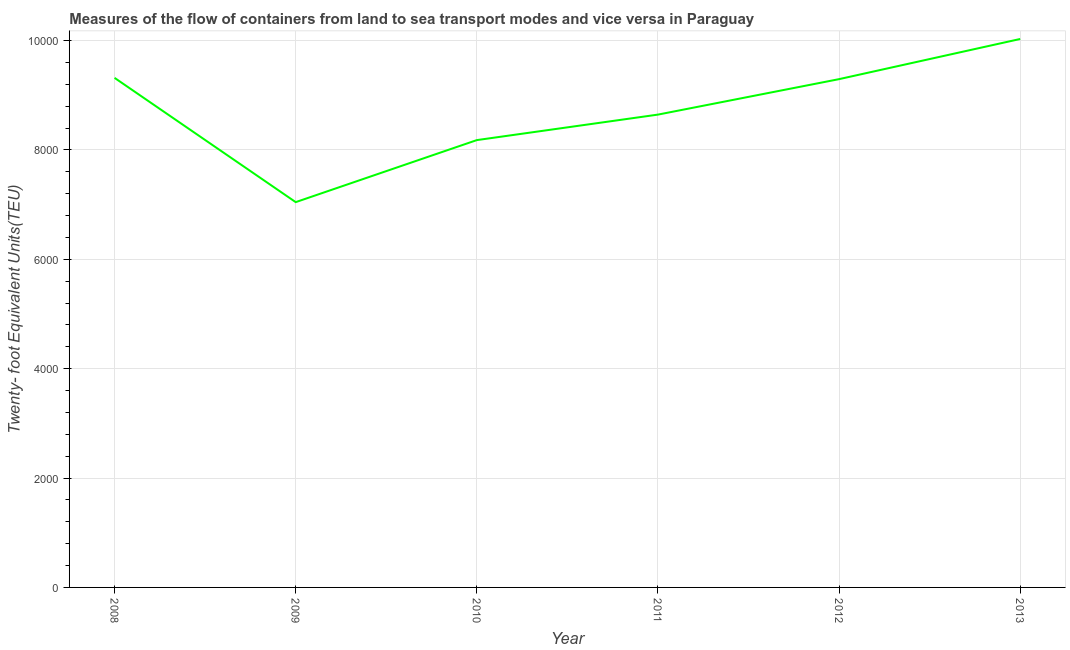What is the container port traffic in 2008?
Make the answer very short. 9317. Across all years, what is the maximum container port traffic?
Your response must be concise. 1.00e+04. Across all years, what is the minimum container port traffic?
Your answer should be very brief. 7045. In which year was the container port traffic maximum?
Your response must be concise. 2013. In which year was the container port traffic minimum?
Your answer should be very brief. 2009. What is the sum of the container port traffic?
Your response must be concise. 5.25e+04. What is the difference between the container port traffic in 2009 and 2013?
Provide a succinct answer. -2983.09. What is the average container port traffic per year?
Provide a short and direct response. 8751.44. What is the median container port traffic?
Make the answer very short. 8969.67. In how many years, is the container port traffic greater than 8400 TEU?
Offer a terse response. 4. What is the ratio of the container port traffic in 2010 to that in 2012?
Your answer should be very brief. 0.88. Is the container port traffic in 2008 less than that in 2009?
Your response must be concise. No. Is the difference between the container port traffic in 2008 and 2013 greater than the difference between any two years?
Make the answer very short. No. What is the difference between the highest and the second highest container port traffic?
Your response must be concise. 711.09. Is the sum of the container port traffic in 2009 and 2012 greater than the maximum container port traffic across all years?
Provide a short and direct response. Yes. What is the difference between the highest and the lowest container port traffic?
Make the answer very short. 2983.09. How many lines are there?
Make the answer very short. 1. Does the graph contain grids?
Your answer should be very brief. Yes. What is the title of the graph?
Your answer should be very brief. Measures of the flow of containers from land to sea transport modes and vice versa in Paraguay. What is the label or title of the X-axis?
Make the answer very short. Year. What is the label or title of the Y-axis?
Keep it short and to the point. Twenty- foot Equivalent Units(TEU). What is the Twenty- foot Equivalent Units(TEU) of 2008?
Offer a very short reply. 9317. What is the Twenty- foot Equivalent Units(TEU) in 2009?
Your answer should be very brief. 7045. What is the Twenty- foot Equivalent Units(TEU) of 2010?
Provide a short and direct response. 8179.24. What is the Twenty- foot Equivalent Units(TEU) of 2011?
Keep it short and to the point. 8645.46. What is the Twenty- foot Equivalent Units(TEU) of 2012?
Give a very brief answer. 9293.87. What is the Twenty- foot Equivalent Units(TEU) in 2013?
Provide a succinct answer. 1.00e+04. What is the difference between the Twenty- foot Equivalent Units(TEU) in 2008 and 2009?
Offer a very short reply. 2272. What is the difference between the Twenty- foot Equivalent Units(TEU) in 2008 and 2010?
Give a very brief answer. 1137.76. What is the difference between the Twenty- foot Equivalent Units(TEU) in 2008 and 2011?
Offer a very short reply. 671.54. What is the difference between the Twenty- foot Equivalent Units(TEU) in 2008 and 2012?
Provide a short and direct response. 23.13. What is the difference between the Twenty- foot Equivalent Units(TEU) in 2008 and 2013?
Keep it short and to the point. -711.09. What is the difference between the Twenty- foot Equivalent Units(TEU) in 2009 and 2010?
Provide a succinct answer. -1134.24. What is the difference between the Twenty- foot Equivalent Units(TEU) in 2009 and 2011?
Provide a short and direct response. -1600.46. What is the difference between the Twenty- foot Equivalent Units(TEU) in 2009 and 2012?
Make the answer very short. -2248.87. What is the difference between the Twenty- foot Equivalent Units(TEU) in 2009 and 2013?
Your answer should be very brief. -2983.09. What is the difference between the Twenty- foot Equivalent Units(TEU) in 2010 and 2011?
Give a very brief answer. -466.22. What is the difference between the Twenty- foot Equivalent Units(TEU) in 2010 and 2012?
Provide a succinct answer. -1114.63. What is the difference between the Twenty- foot Equivalent Units(TEU) in 2010 and 2013?
Offer a terse response. -1848.84. What is the difference between the Twenty- foot Equivalent Units(TEU) in 2011 and 2012?
Make the answer very short. -648.41. What is the difference between the Twenty- foot Equivalent Units(TEU) in 2011 and 2013?
Your response must be concise. -1382.63. What is the difference between the Twenty- foot Equivalent Units(TEU) in 2012 and 2013?
Provide a short and direct response. -734.22. What is the ratio of the Twenty- foot Equivalent Units(TEU) in 2008 to that in 2009?
Give a very brief answer. 1.32. What is the ratio of the Twenty- foot Equivalent Units(TEU) in 2008 to that in 2010?
Give a very brief answer. 1.14. What is the ratio of the Twenty- foot Equivalent Units(TEU) in 2008 to that in 2011?
Offer a terse response. 1.08. What is the ratio of the Twenty- foot Equivalent Units(TEU) in 2008 to that in 2013?
Keep it short and to the point. 0.93. What is the ratio of the Twenty- foot Equivalent Units(TEU) in 2009 to that in 2010?
Your answer should be very brief. 0.86. What is the ratio of the Twenty- foot Equivalent Units(TEU) in 2009 to that in 2011?
Your answer should be very brief. 0.81. What is the ratio of the Twenty- foot Equivalent Units(TEU) in 2009 to that in 2012?
Keep it short and to the point. 0.76. What is the ratio of the Twenty- foot Equivalent Units(TEU) in 2009 to that in 2013?
Give a very brief answer. 0.7. What is the ratio of the Twenty- foot Equivalent Units(TEU) in 2010 to that in 2011?
Provide a short and direct response. 0.95. What is the ratio of the Twenty- foot Equivalent Units(TEU) in 2010 to that in 2012?
Provide a short and direct response. 0.88. What is the ratio of the Twenty- foot Equivalent Units(TEU) in 2010 to that in 2013?
Keep it short and to the point. 0.82. What is the ratio of the Twenty- foot Equivalent Units(TEU) in 2011 to that in 2013?
Give a very brief answer. 0.86. What is the ratio of the Twenty- foot Equivalent Units(TEU) in 2012 to that in 2013?
Give a very brief answer. 0.93. 